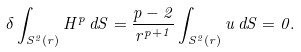Convert formula to latex. <formula><loc_0><loc_0><loc_500><loc_500>\delta \int _ { S ^ { 2 } ( r ) } H ^ { p } \, d S = \frac { p - 2 } { r ^ { p + 1 } } \int _ { S ^ { 2 } ( r ) } u \, d S = 0 .</formula> 